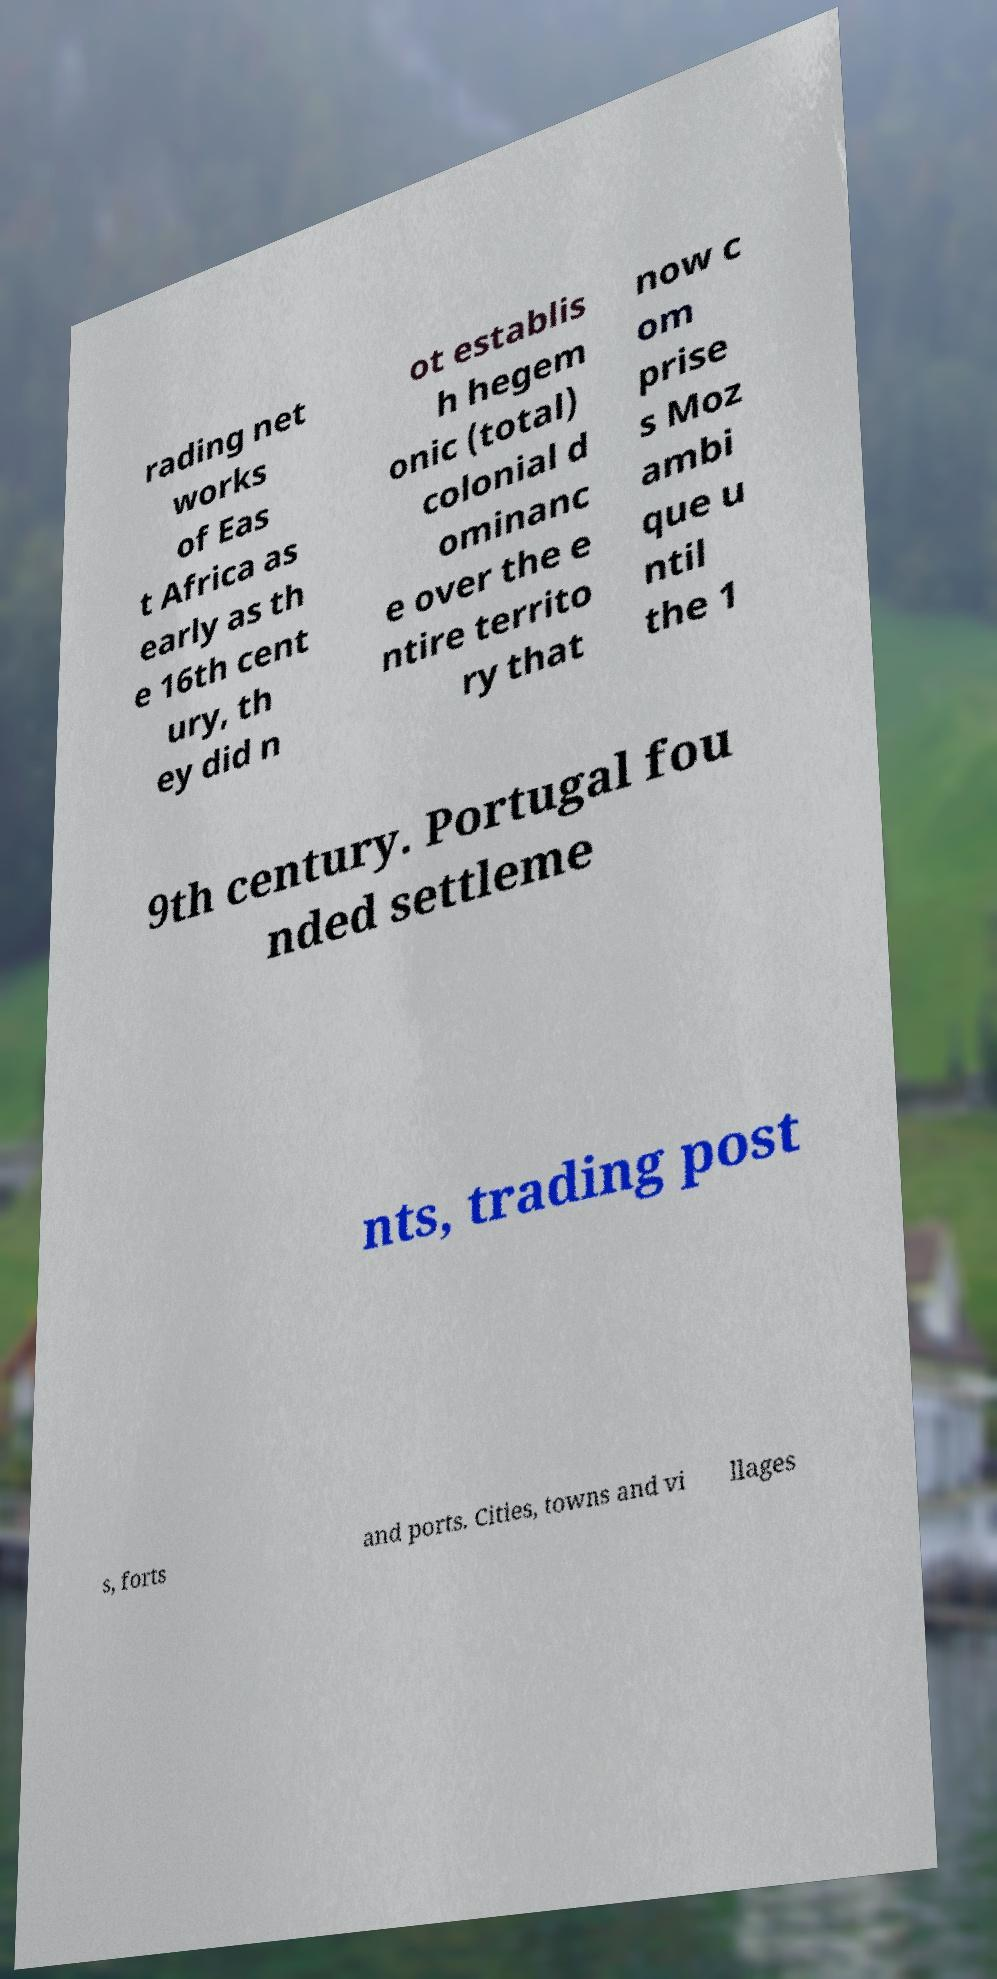Can you accurately transcribe the text from the provided image for me? rading net works of Eas t Africa as early as th e 16th cent ury, th ey did n ot establis h hegem onic (total) colonial d ominanc e over the e ntire territo ry that now c om prise s Moz ambi que u ntil the 1 9th century. Portugal fou nded settleme nts, trading post s, forts and ports. Cities, towns and vi llages 